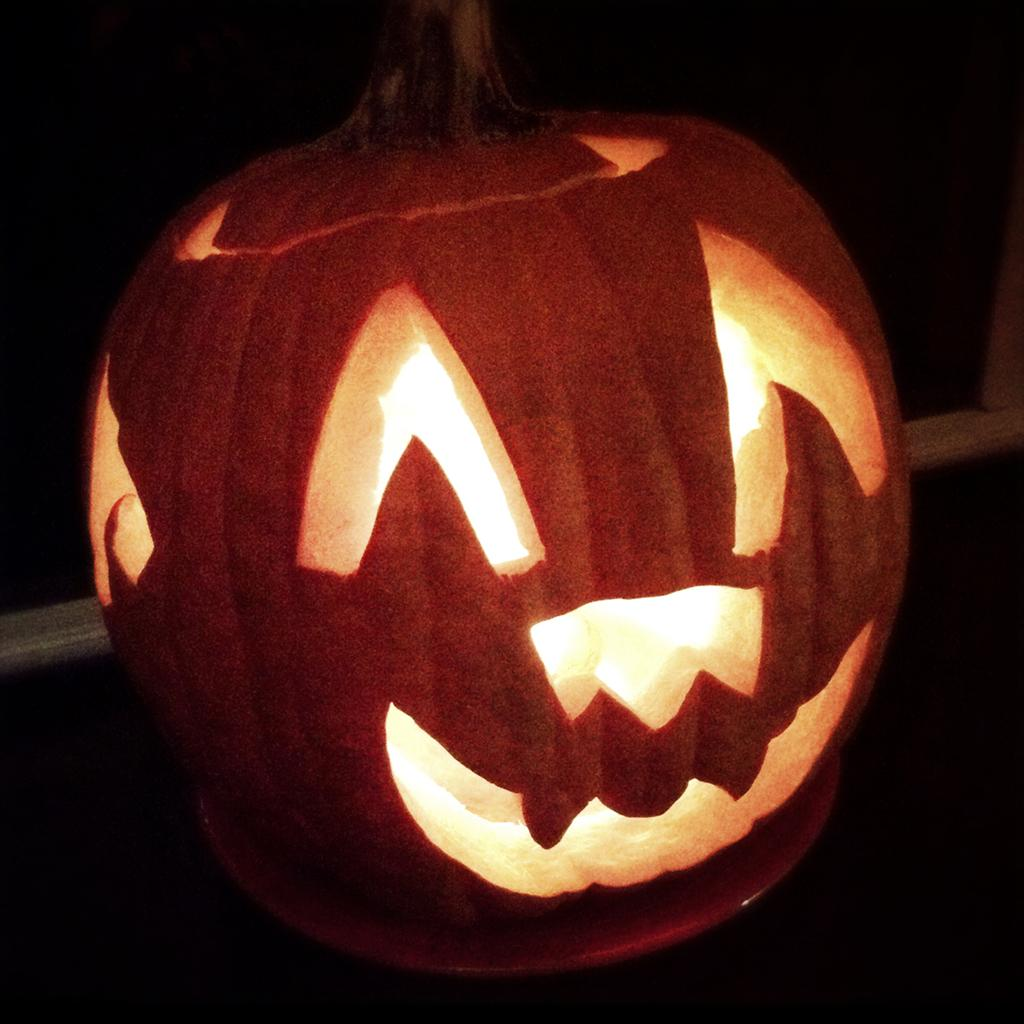What is the main object in the image? There is a carved pumpkin in the image. Where is the carved pumpkin located? The carved pumpkin is placed on a surface. What type of cake is being served on the love seat in the image? There is no cake or love seat present in the image; it only features a carved pumpkin placed on a surface. 